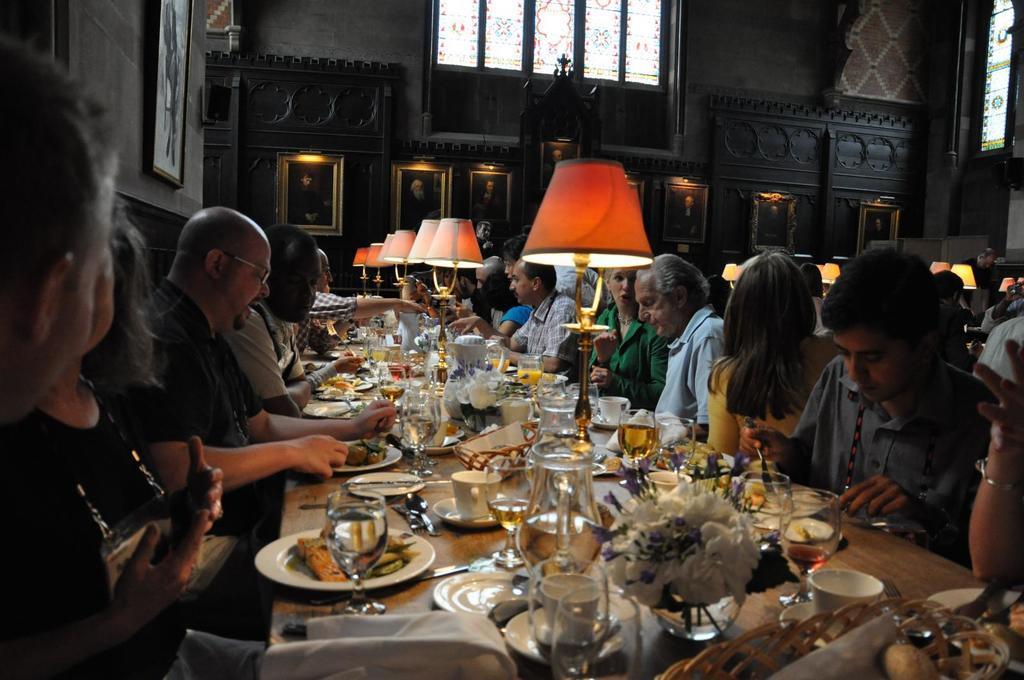Please provide a concise description of this image. In this image we can see many people are sitting around the table. We can see plates with food, glasses, jars, cups, spoons and forks, flower vases and lamps on the table. In the background we can see photo frames on the wall. 